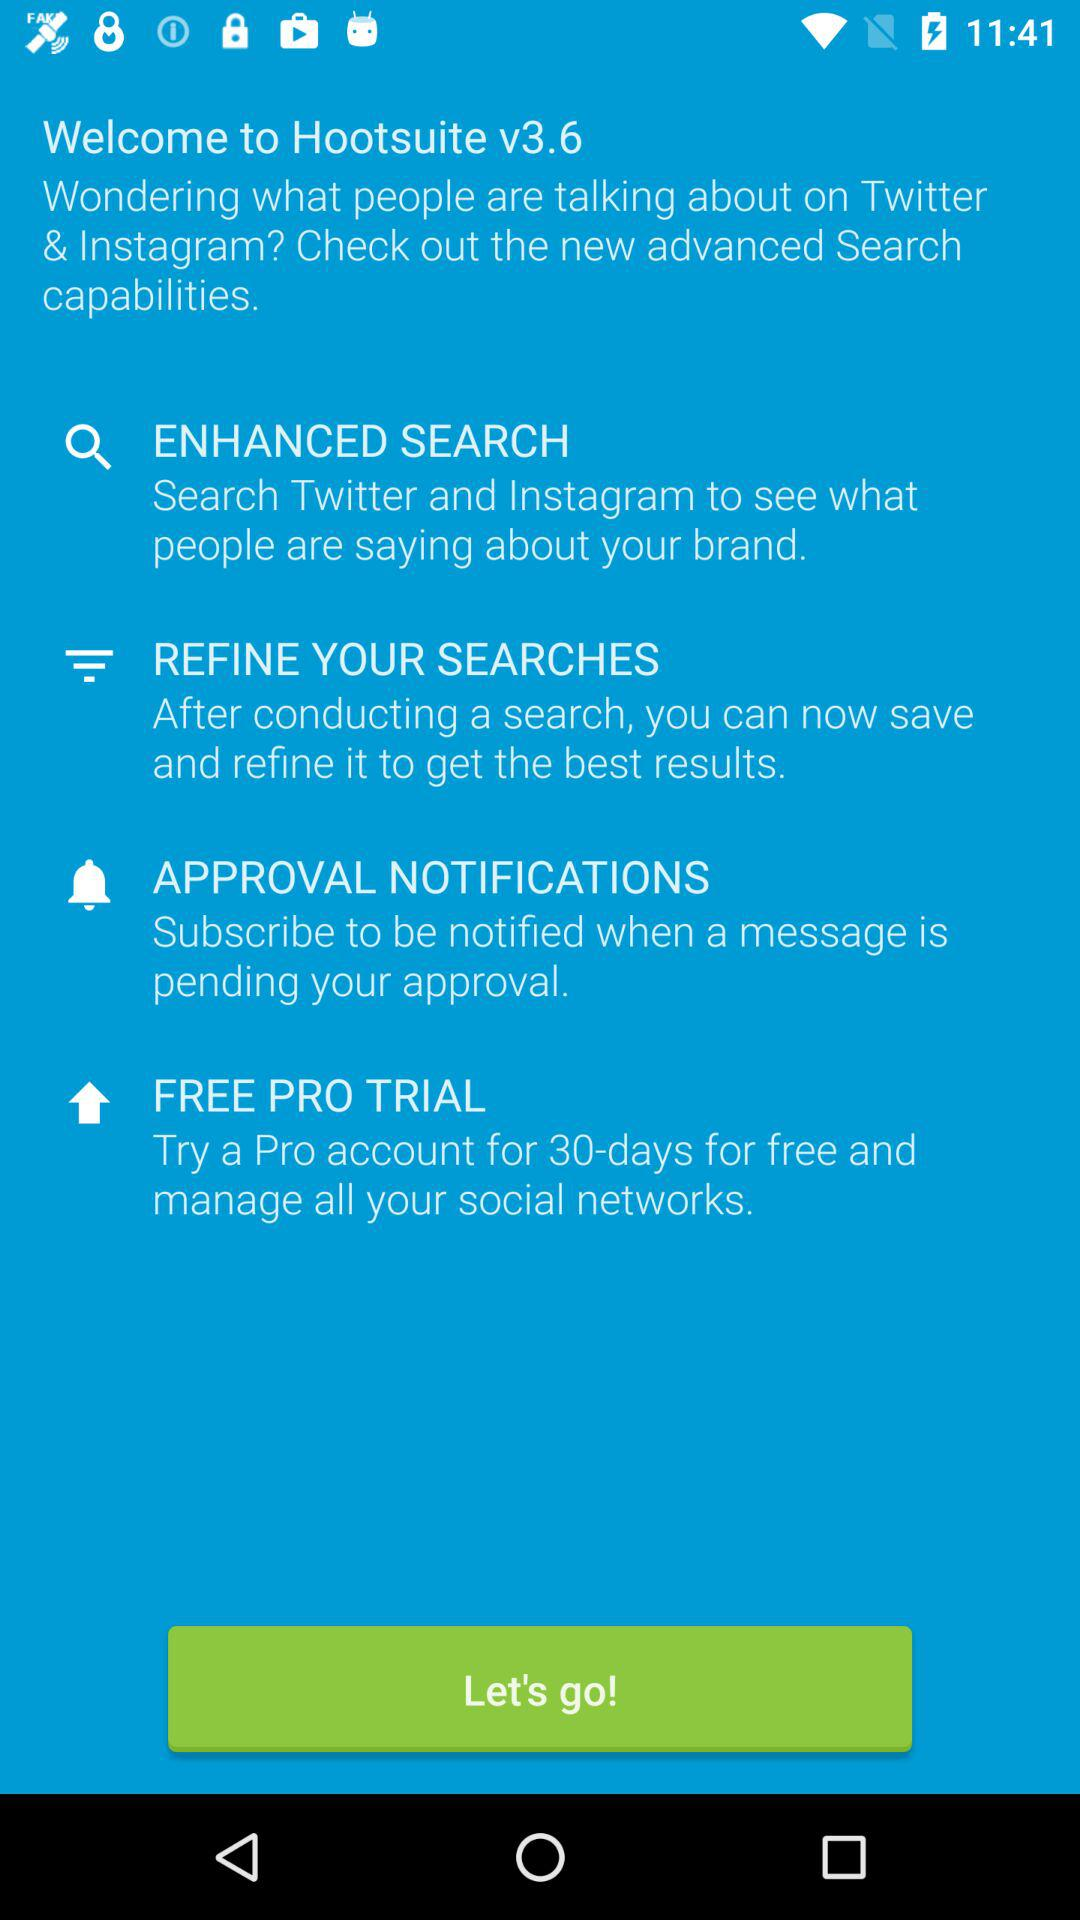What is the version of "Hootsuite"? The version is v3.6. 